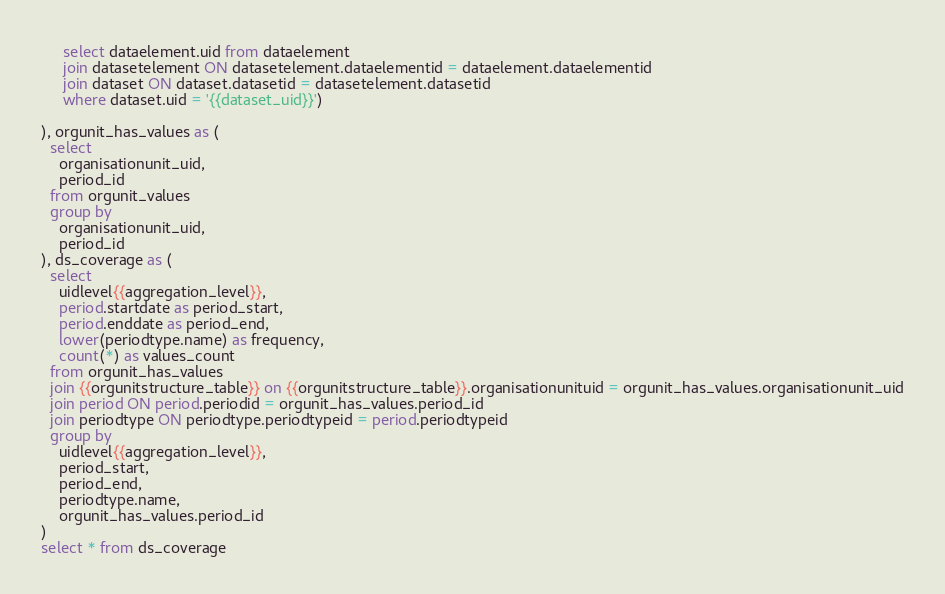Convert code to text. <code><loc_0><loc_0><loc_500><loc_500><_SQL_>     select dataelement.uid from dataelement
     join datasetelement ON datasetelement.dataelementid = dataelement.dataelementid
     join dataset ON dataset.datasetid = datasetelement.datasetid
     where dataset.uid = '{{dataset_uid}}')

), orgunit_has_values as (
  select
    organisationunit_uid,
    period_id
  from orgunit_values
  group by
    organisationunit_uid,
    period_id
), ds_coverage as (
  select
    uidlevel{{aggregation_level}},
    period.startdate as period_start,
    period.enddate as period_end,
    lower(periodtype.name) as frequency,
    count(*) as values_count
  from orgunit_has_values
  join {{orgunitstructure_table}} on {{orgunitstructure_table}}.organisationunituid = orgunit_has_values.organisationunit_uid
  join period ON period.periodid = orgunit_has_values.period_id
  join periodtype ON periodtype.periodtypeid = period.periodtypeid
  group by
    uidlevel{{aggregation_level}},
    period_start,
    period_end,
    periodtype.name,
    orgunit_has_values.period_id
)
select * from ds_coverage</code> 